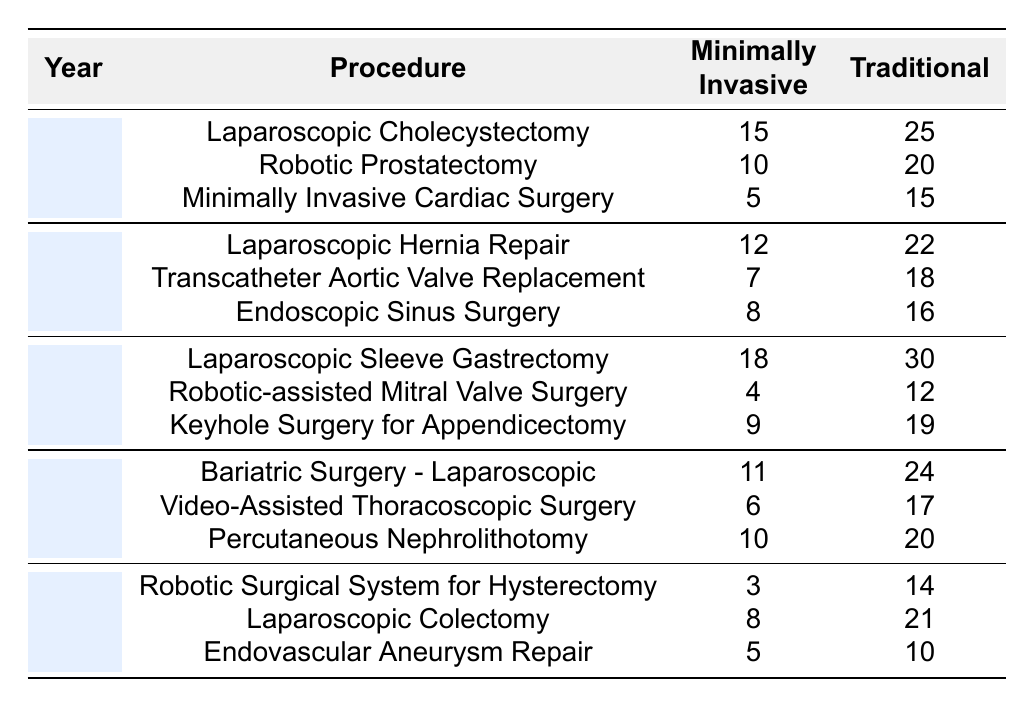What is the total number of complications for minimally invasive procedures in 2021? In 2021, the minimally invasive complications for three procedures are: 18 (Laparoscopic Sleeve Gastrectomy), 4 (Robotic-assisted Mitral Valve Surgery), and 9 (Keyhole Surgery for Appendicectomy). Summing these up gives 18 + 4 + 9 = 31.
Answer: 31 What was the complication rate for traditional procedures in 2020? In 2020, the traditional complications for three procedures are: 22 (Laparoscopic Hernia Repair), 18 (Transcatheter Aortic Valve Replacement), and 16 (Endoscopic Sinus Surgery). Adding these, we have 22 + 18 + 16 = 56.
Answer: 56 Which procedure had the highest complication rate in minimally invasive surgery in 2019? In 2019, the complications for minimally invasive procedures were: 15 (Laparoscopic Cholecystectomy), 10 (Robotic Prostatectomy), and 5 (Minimally Invasive Cardiac Surgery). The highest is 15 from Laparoscopic Cholecystectomy.
Answer: Laparoscopic Cholecystectomy Did minimally invasive procedures have a lower complication rate than traditional procedures in the year 2023? In 2023, the minimally invasive complications were 3 (Robotic Surgical System for Hysterectomy), 8 (Laparoscopic Colectomy), and 5 (Endovascular Aneurysm Repair). The traditional complications were 14, 21, and 10 respectively. Summed up, minimally invasive had 3 + 8 + 5 = 16 while traditional had 14 + 21 + 10 = 45. Since 16 < 45, minimally invasive had a lower complication rate.
Answer: Yes What was the average complication rate for traditional surgeries across all years in this data? The traditional complications per year are: 25 (2019), 22 (2020), 30 (2021), 24 (2022), and 14 (2023). Summing gives 25 + 22 + 30 + 24 + 14 = 115, and dividing by the number of years (5) gives an average of 115 / 5 = 23.
Answer: 23 In which year did minimally invasive procedures demonstrate the lowest overall complication rate? Summing the minimally invasive complications per year gives: 15 + 10 + 5 = 30 (2019), 12 + 7 + 8 = 27 (2020), 18 + 4 + 9 = 31 (2021), 11 + 6 + 10 = 27 (2022), and 3 + 8 + 5 = 16 (2023). The lowest sum is 16 in 2023.
Answer: 2023 How does the sum of complications for traditional surgery in 2021 compare to that in 2022? In 2021, traditional complications totaled: 30 (Laparoscopic Sleeve Gastrectomy) + 12 (Robotic-assisted Mitral Valve Surgery) + 19 (Keyhole Surgery) = 61. In 2022, the total is: 24 (Bariatric Surgery) + 17 (Video-Assisted Thoracoscopic Surgery) + 20 (Percutaneous Nephrolithotomy) = 61. Since 61 = 61, they are equal.
Answer: They are equal 